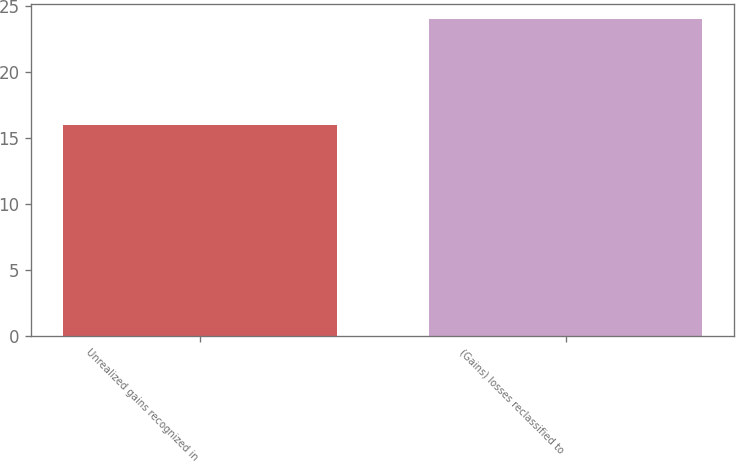Convert chart. <chart><loc_0><loc_0><loc_500><loc_500><bar_chart><fcel>Unrealized gains recognized in<fcel>(Gains) losses reclassified to<nl><fcel>16<fcel>24<nl></chart> 